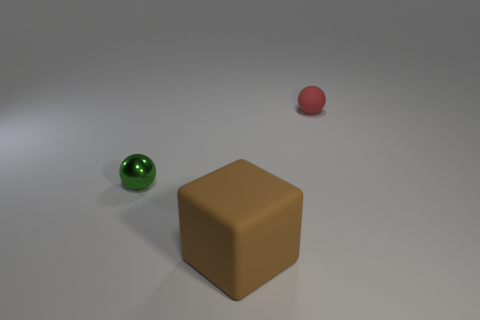Could you describe the lighting condition in the image? The lighting in the image appears to be diffused, with a soft shadow cast beneath the objects indicating a single light source above. There are no harsh shadows or highlights, which suggests that the environment is softly lit, likely in an indoor setting. 